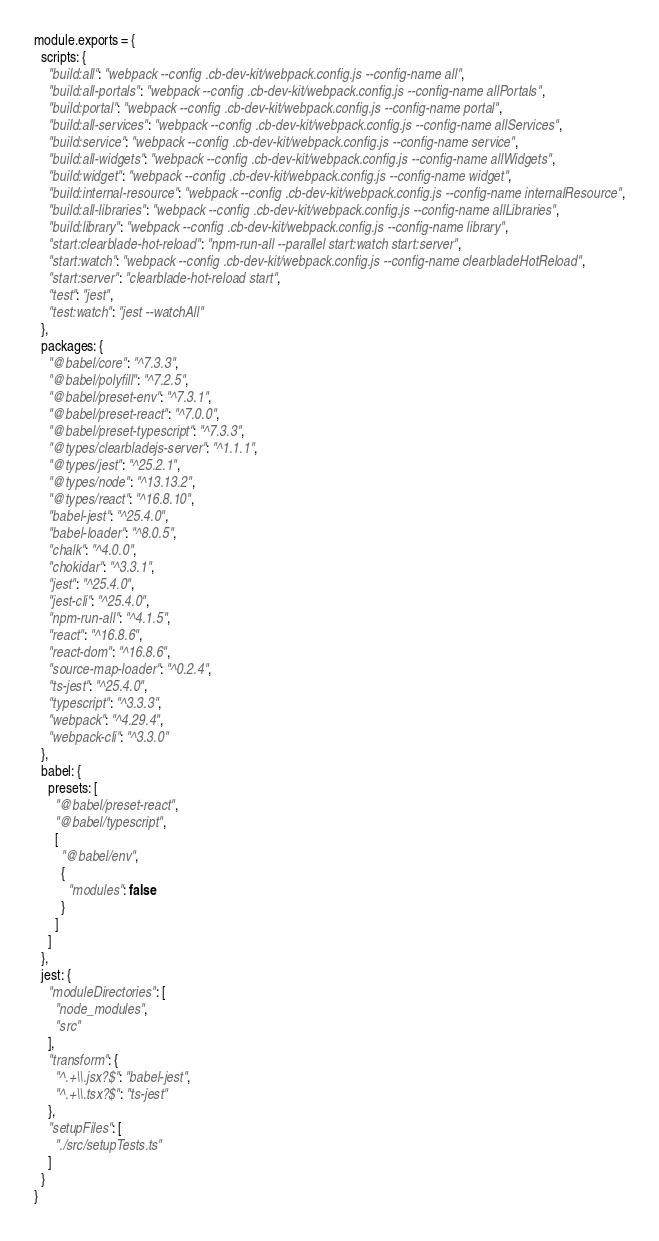<code> <loc_0><loc_0><loc_500><loc_500><_JavaScript_>module.exports = {
  scripts: {
    "build:all": "webpack --config .cb-dev-kit/webpack.config.js --config-name all",
    "build:all-portals": "webpack --config .cb-dev-kit/webpack.config.js --config-name allPortals",
    "build:portal": "webpack --config .cb-dev-kit/webpack.config.js --config-name portal",
    "build:all-services": "webpack --config .cb-dev-kit/webpack.config.js --config-name allServices",
    "build:service": "webpack --config .cb-dev-kit/webpack.config.js --config-name service",
    "build:all-widgets": "webpack --config .cb-dev-kit/webpack.config.js --config-name allWidgets",
    "build:widget": "webpack --config .cb-dev-kit/webpack.config.js --config-name widget",
    "build:internal-resource": "webpack --config .cb-dev-kit/webpack.config.js --config-name internalResource",
    "build:all-libraries": "webpack --config .cb-dev-kit/webpack.config.js --config-name allLibraries",
    "build:library": "webpack --config .cb-dev-kit/webpack.config.js --config-name library",
    "start:clearblade-hot-reload": "npm-run-all --parallel start:watch start:server",
    "start:watch": "webpack --config .cb-dev-kit/webpack.config.js --config-name clearbladeHotReload",
    "start:server": "clearblade-hot-reload start",
    "test": "jest",
    "test:watch": "jest --watchAll"
  },
  packages: {
    "@babel/core": "^7.3.3",
    "@babel/polyfill": "^7.2.5",
    "@babel/preset-env": "^7.3.1",
    "@babel/preset-react": "^7.0.0",
    "@babel/preset-typescript": "^7.3.3",
    "@types/clearbladejs-server": "^1.1.1",
    "@types/jest": "^25.2.1",
    "@types/node": "^13.13.2",
    "@types/react": "^16.8.10",
    "babel-jest": "^25.4.0",
    "babel-loader": "^8.0.5",
    "chalk": "^4.0.0",
    "chokidar": "^3.3.1",
    "jest": "^25.4.0",
    "jest-cli": "^25.4.0",
    "npm-run-all": "^4.1.5",
    "react": "^16.8.6",
    "react-dom": "^16.8.6",
    "source-map-loader": "^0.2.4",
    "ts-jest": "^25.4.0",
    "typescript": "^3.3.3",
    "webpack": "^4.29.4",
    "webpack-cli": "^3.3.0"
  },
  babel: {
    presets: [
      "@babel/preset-react",
      "@babel/typescript",
      [
        "@babel/env",
        {
          "modules": false
        }
      ]
    ]
  },
  jest: {
    "moduleDirectories": [
      "node_modules",
      "src"
    ],
    "transform": {
      "^.+\\.jsx?$": "babel-jest",
      "^.+\\.tsx?$": "ts-jest"
    },
    "setupFiles": [
      "./src/setupTests.ts"
    ]
  }
}</code> 